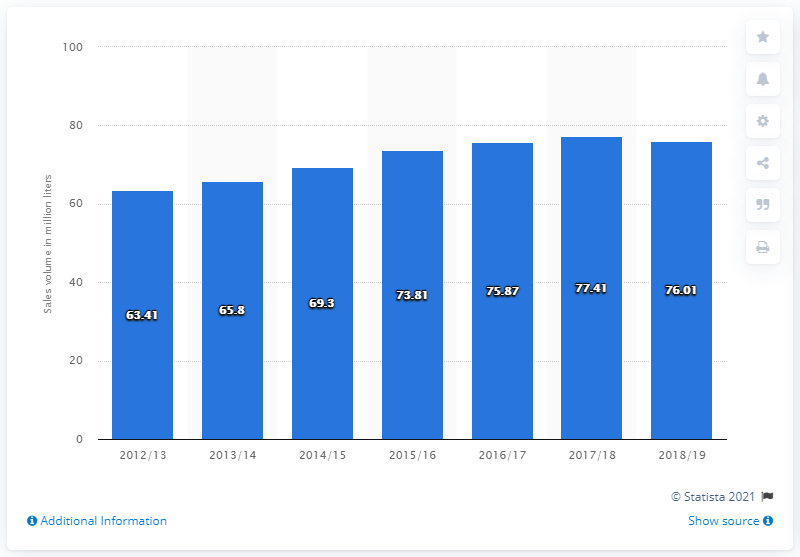Mention a couple of crucial points in this snapshot. The sales volume of wine in British Columbia during the fiscal year ending in March 2019 was 76.01 million units. 